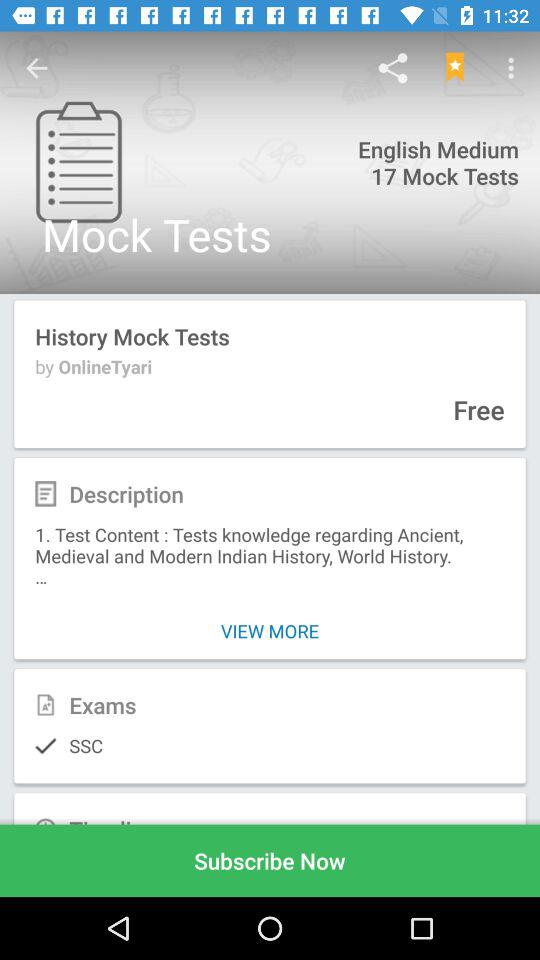Which exam have the most people selected?
When the provided information is insufficient, respond with <no answer>. <no answer> 